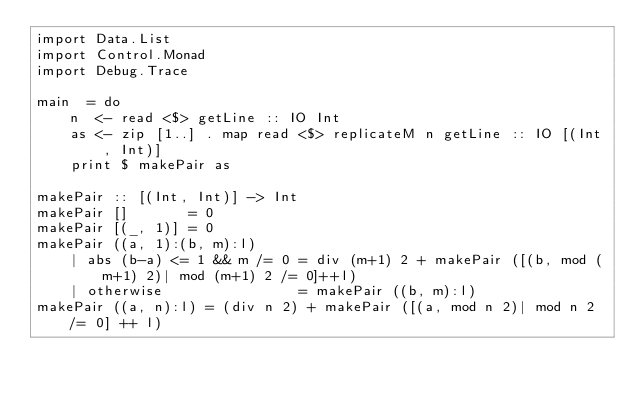<code> <loc_0><loc_0><loc_500><loc_500><_Haskell_>import Data.List
import Control.Monad
import Debug.Trace

main  = do
    n  <- read <$> getLine :: IO Int
    as <- zip [1..] . map read <$> replicateM n getLine :: IO [(Int, Int)]
    print $ makePair as

makePair :: [(Int, Int)] -> Int
makePair []       = 0
makePair [(_, 1)] = 0
makePair ((a, 1):(b, m):l)
    | abs (b-a) <= 1 && m /= 0 = div (m+1) 2 + makePair ([(b, mod (m+1) 2)| mod (m+1) 2 /= 0]++l)
    | otherwise                = makePair ((b, m):l)
makePair ((a, n):l) = (div n 2) + makePair ([(a, mod n 2)| mod n 2 /= 0] ++ l)</code> 